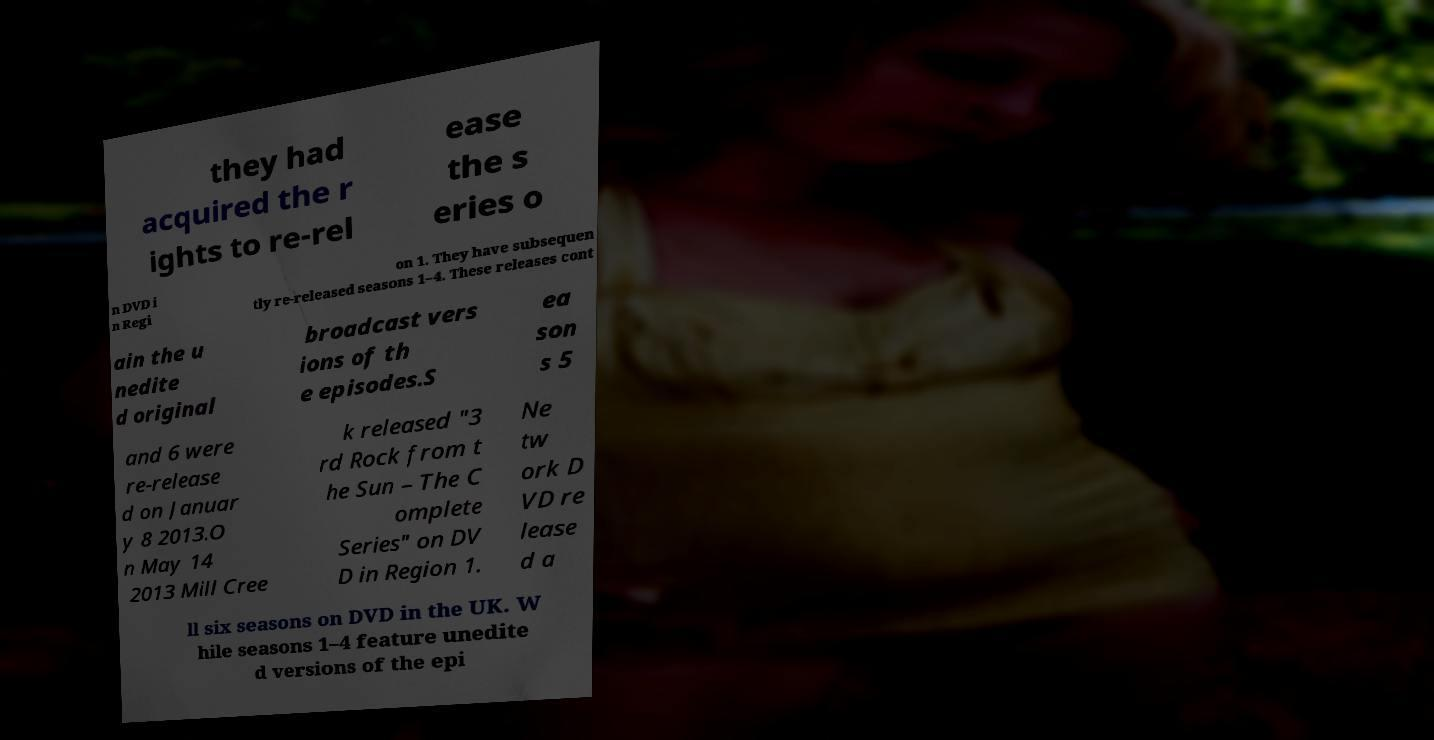Please identify and transcribe the text found in this image. they had acquired the r ights to re-rel ease the s eries o n DVD i n Regi on 1. They have subsequen tly re-released seasons 1–4. These releases cont ain the u nedite d original broadcast vers ions of th e episodes.S ea son s 5 and 6 were re-release d on Januar y 8 2013.O n May 14 2013 Mill Cree k released "3 rd Rock from t he Sun – The C omplete Series" on DV D in Region 1. Ne tw ork D VD re lease d a ll six seasons on DVD in the UK. W hile seasons 1–4 feature unedite d versions of the epi 